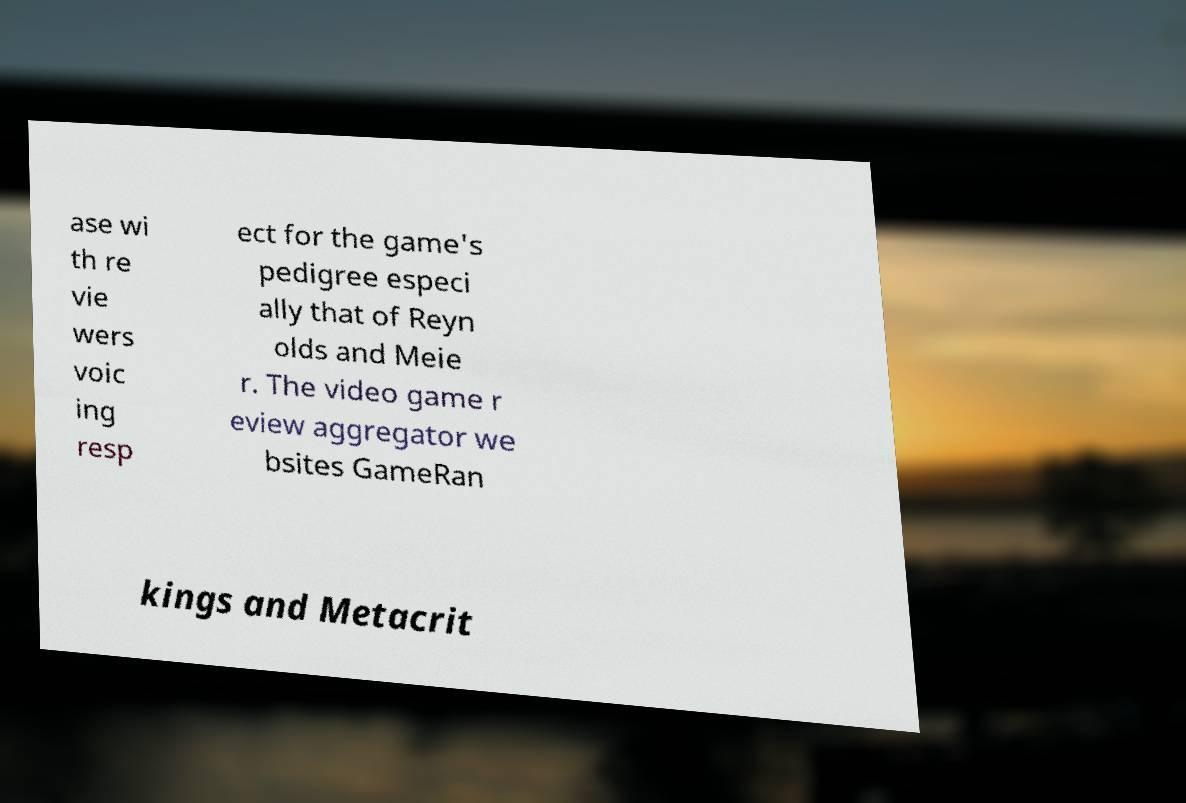Can you read and provide the text displayed in the image?This photo seems to have some interesting text. Can you extract and type it out for me? ase wi th re vie wers voic ing resp ect for the game's pedigree especi ally that of Reyn olds and Meie r. The video game r eview aggregator we bsites GameRan kings and Metacrit 